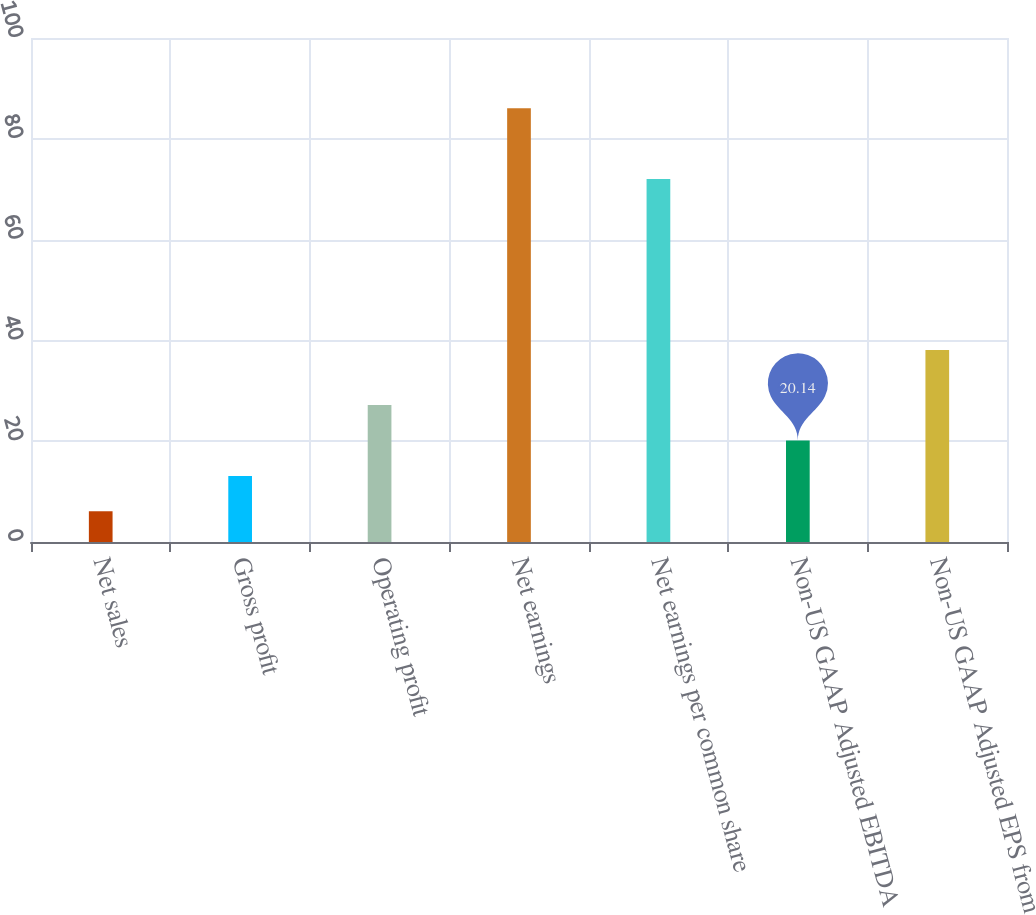Convert chart to OTSL. <chart><loc_0><loc_0><loc_500><loc_500><bar_chart><fcel>Net sales<fcel>Gross profit<fcel>Operating profit<fcel>Net earnings<fcel>Net earnings per common share<fcel>Non-US GAAP Adjusted EBITDA<fcel>Non-US GAAP Adjusted EPS from<nl><fcel>6.1<fcel>13.12<fcel>27.16<fcel>86.04<fcel>72<fcel>20.14<fcel>38.1<nl></chart> 